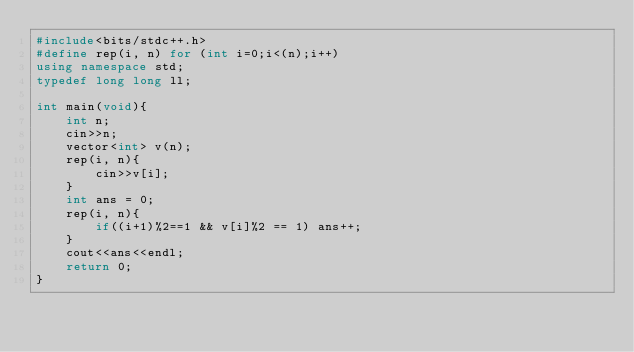Convert code to text. <code><loc_0><loc_0><loc_500><loc_500><_C++_>#include<bits/stdc++.h>
#define rep(i, n) for (int i=0;i<(n);i++)
using namespace std;
typedef long long ll;
 
int main(void){
    int n;
    cin>>n;
    vector<int> v(n);
    rep(i, n){
        cin>>v[i];
    }
    int ans = 0;
    rep(i, n){
        if((i+1)%2==1 && v[i]%2 == 1) ans++;
    }
    cout<<ans<<endl;
    return 0;
}</code> 